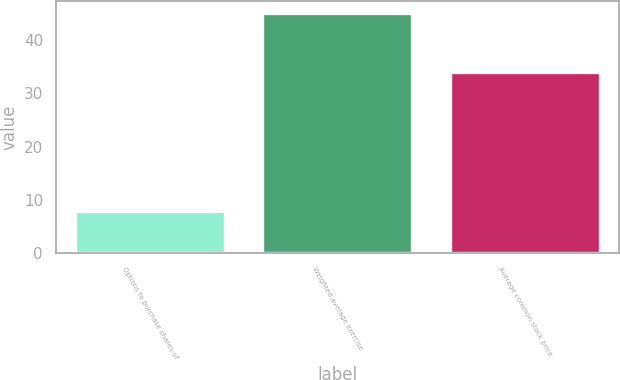Convert chart. <chart><loc_0><loc_0><loc_500><loc_500><bar_chart><fcel>Options to purchase shares of<fcel>Weighted-average exercise<fcel>Average common stock price<nl><fcel>8<fcel>45<fcel>34<nl></chart> 